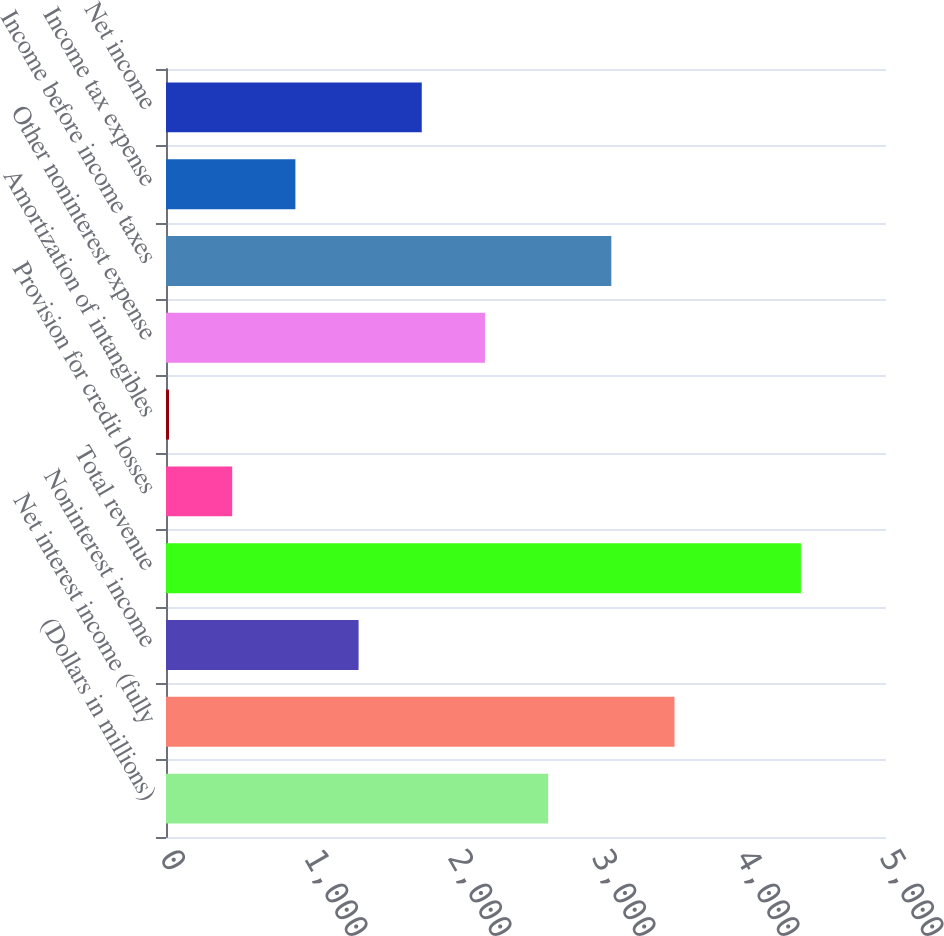Convert chart. <chart><loc_0><loc_0><loc_500><loc_500><bar_chart><fcel>(Dollars in millions)<fcel>Net interest income (fully<fcel>Noninterest income<fcel>Total revenue<fcel>Provision for credit losses<fcel>Amortization of intangibles<fcel>Other noninterest expense<fcel>Income before income taxes<fcel>Income tax expense<fcel>Net income<nl><fcel>2653.8<fcel>3531.4<fcel>1337.4<fcel>4409<fcel>459.8<fcel>21<fcel>2215<fcel>3092.6<fcel>898.6<fcel>1776.2<nl></chart> 